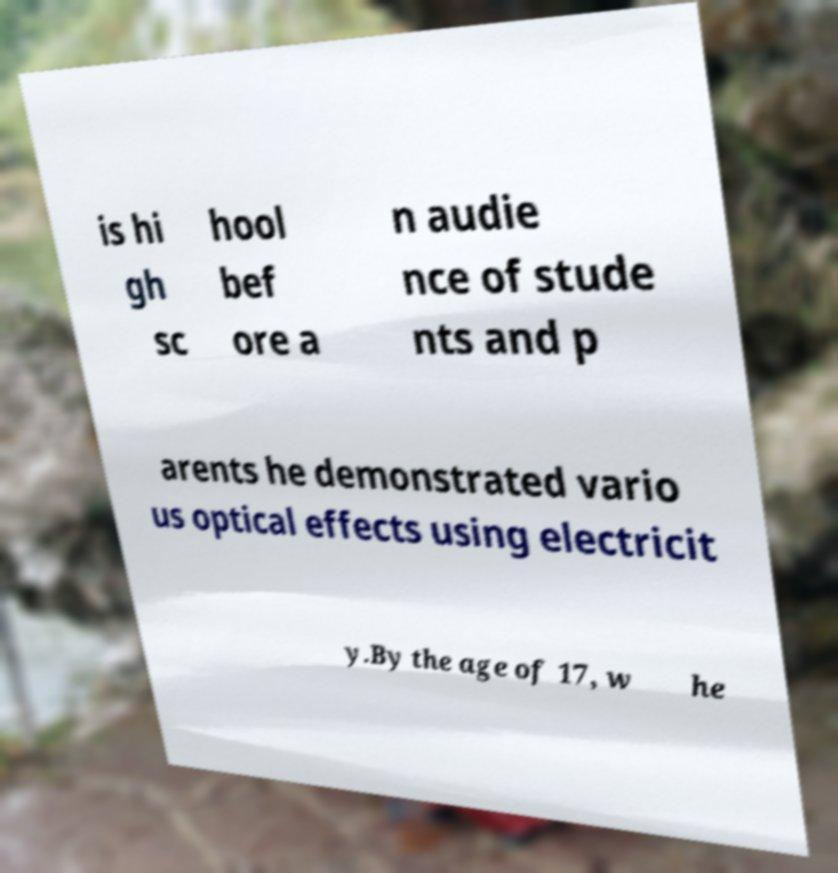Can you accurately transcribe the text from the provided image for me? is hi gh sc hool bef ore a n audie nce of stude nts and p arents he demonstrated vario us optical effects using electricit y.By the age of 17, w he 